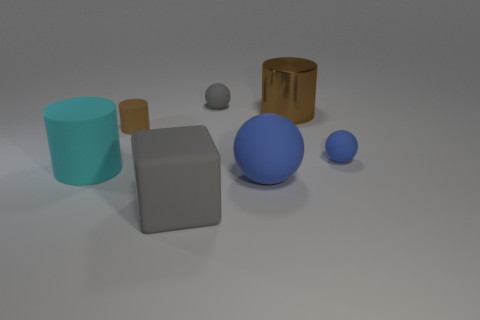There is a shiny thing that is the same color as the small cylinder; what is its shape?
Ensure brevity in your answer.  Cylinder. Are there any matte cylinders?
Provide a short and direct response. Yes. There is a brown shiny cylinder; is its size the same as the blue rubber thing to the right of the large brown cylinder?
Offer a very short reply. No. Are there any blue spheres behind the brown cylinder that is to the left of the cube?
Your answer should be compact. No. What is the object that is in front of the large cyan cylinder and behind the large matte block made of?
Ensure brevity in your answer.  Rubber. There is a small sphere that is on the left side of the brown cylinder that is right of the matte cylinder behind the cyan matte cylinder; what is its color?
Your response must be concise. Gray. The block that is the same size as the cyan cylinder is what color?
Keep it short and to the point. Gray. There is a big metallic object; is it the same color as the rubber cylinder behind the small blue thing?
Provide a short and direct response. Yes. What is the brown cylinder that is to the right of the blue matte thing that is on the left side of the big brown cylinder made of?
Your answer should be compact. Metal. What number of things are in front of the metal cylinder and behind the large rubber block?
Your response must be concise. 4. 